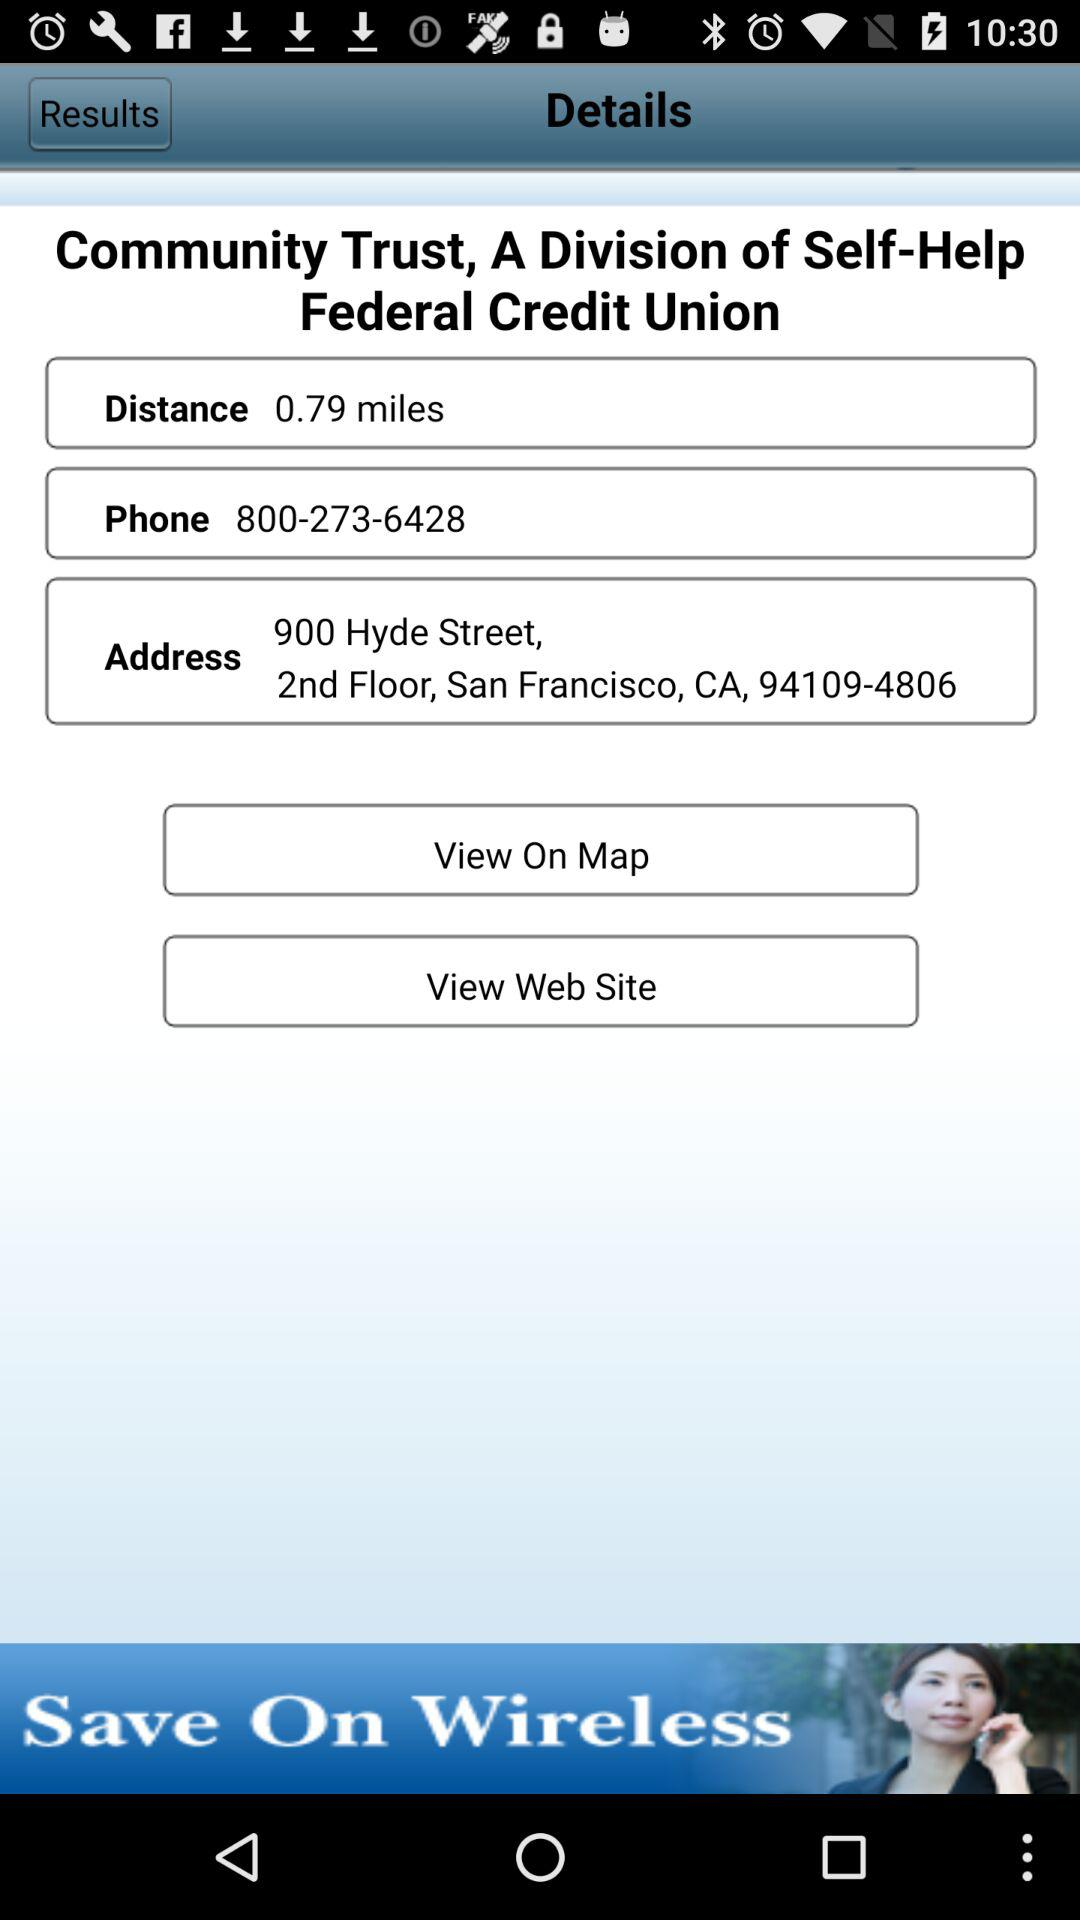Which are the different options to view? The different options to view are "Map" and "Web Site". 